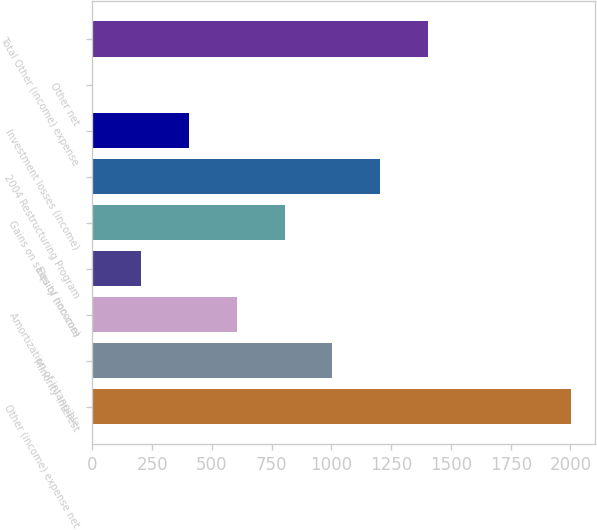<chart> <loc_0><loc_0><loc_500><loc_500><bar_chart><fcel>Other (income) expense net<fcel>Minority interest<fcel>Amortization of intangible<fcel>Equity (income)<fcel>Gains on sales of non-core<fcel>2004 Restructuring Program<fcel>Investment losses (income)<fcel>Other net<fcel>Total Other (income) expense<nl><fcel>2004<fcel>1003.95<fcel>603.93<fcel>203.91<fcel>803.94<fcel>1203.96<fcel>403.92<fcel>3.9<fcel>1403.97<nl></chart> 